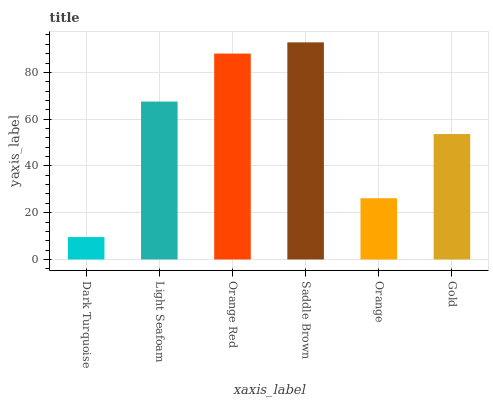Is Dark Turquoise the minimum?
Answer yes or no. Yes. Is Saddle Brown the maximum?
Answer yes or no. Yes. Is Light Seafoam the minimum?
Answer yes or no. No. Is Light Seafoam the maximum?
Answer yes or no. No. Is Light Seafoam greater than Dark Turquoise?
Answer yes or no. Yes. Is Dark Turquoise less than Light Seafoam?
Answer yes or no. Yes. Is Dark Turquoise greater than Light Seafoam?
Answer yes or no. No. Is Light Seafoam less than Dark Turquoise?
Answer yes or no. No. Is Light Seafoam the high median?
Answer yes or no. Yes. Is Gold the low median?
Answer yes or no. Yes. Is Dark Turquoise the high median?
Answer yes or no. No. Is Light Seafoam the low median?
Answer yes or no. No. 